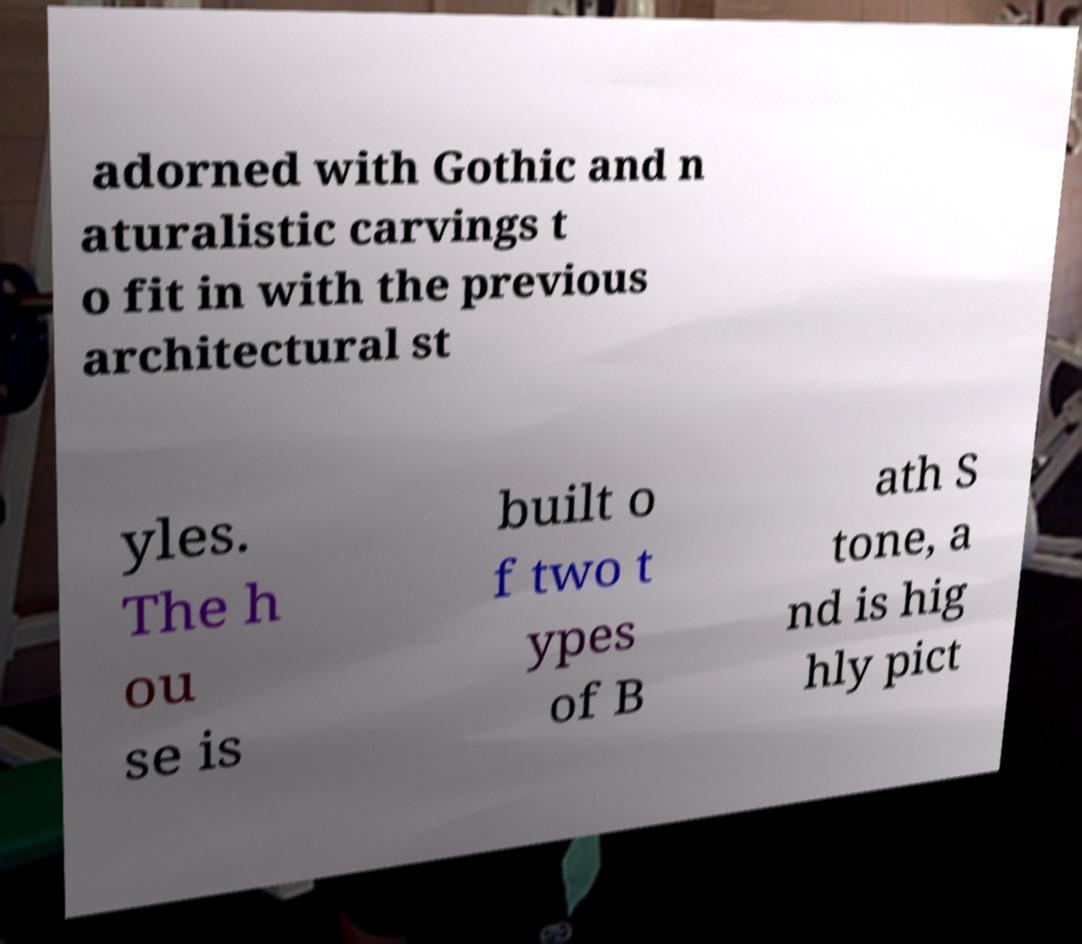Can you read and provide the text displayed in the image?This photo seems to have some interesting text. Can you extract and type it out for me? adorned with Gothic and n aturalistic carvings t o fit in with the previous architectural st yles. The h ou se is built o f two t ypes of B ath S tone, a nd is hig hly pict 